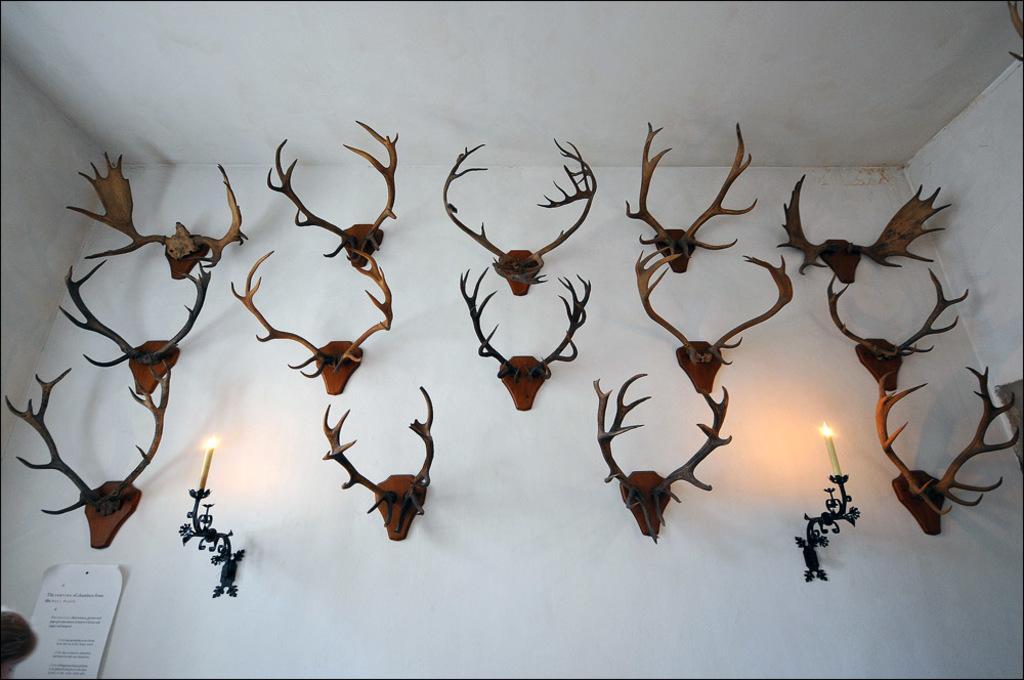Could you give a brief overview of what you see in this image? In this picture we can see a wall, there are some deer antler mounts on the wall, we can see two candle holders and two candles here, at the left bottom we can see a paper pasted on the wall. 